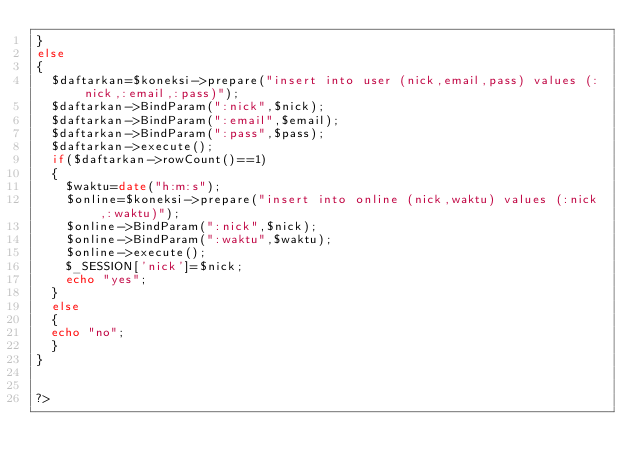Convert code to text. <code><loc_0><loc_0><loc_500><loc_500><_PHP_>}
else
{
	$daftarkan=$koneksi->prepare("insert into user (nick,email,pass) values (:nick,:email,:pass)");
	$daftarkan->BindParam(":nick",$nick);
	$daftarkan->BindParam(":email",$email);
	$daftarkan->BindParam(":pass",$pass);
	$daftarkan->execute();
	if($daftarkan->rowCount()==1)
	{
		$waktu=date("h:m:s");
		$online=$koneksi->prepare("insert into online (nick,waktu) values (:nick,:waktu)");
		$online->BindParam(":nick",$nick);
		$online->BindParam(":waktu",$waktu);
		$online->execute();
		$_SESSION['nick']=$nick;
		echo "yes";
	}
	else
	{
	echo "no";
	}
}


?>
</code> 